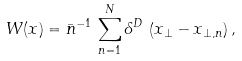<formula> <loc_0><loc_0><loc_500><loc_500>W ( x ) = \bar { n } ^ { - 1 } \, \sum _ { n = 1 } ^ { N } \delta ^ { D } \, \left ( x _ { \perp } - x _ { \perp , n } \right ) ,</formula> 